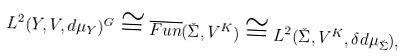<formula> <loc_0><loc_0><loc_500><loc_500>L ^ { 2 } ( Y , V , { d } \mu _ { Y } ) ^ { G } \cong \overline { F u n } ( \check { \Sigma } , V ^ { K } ) \cong L ^ { 2 } ( \check { \Sigma } , V ^ { K } , \delta { d } \mu _ { \check { \Sigma } } ) ,</formula> 